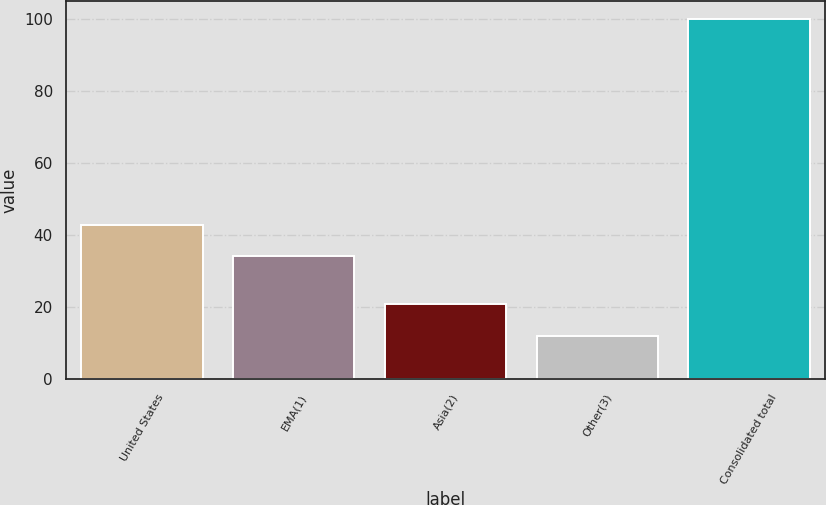<chart> <loc_0><loc_0><loc_500><loc_500><bar_chart><fcel>United States<fcel>EMA(1)<fcel>Asia(2)<fcel>Other(3)<fcel>Consolidated total<nl><fcel>42.89<fcel>34.1<fcel>20.89<fcel>12.1<fcel>100<nl></chart> 